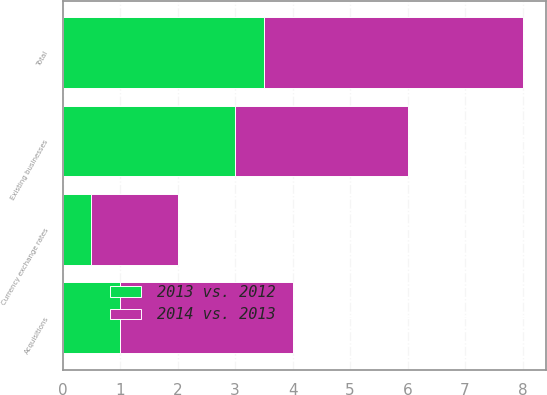Convert chart to OTSL. <chart><loc_0><loc_0><loc_500><loc_500><stacked_bar_chart><ecel><fcel>Existing businesses<fcel>Acquisitions<fcel>Currency exchange rates<fcel>Total<nl><fcel>2014 vs. 2013<fcel>3<fcel>3<fcel>1.5<fcel>4.5<nl><fcel>2013 vs. 2012<fcel>3<fcel>1<fcel>0.5<fcel>3.5<nl></chart> 